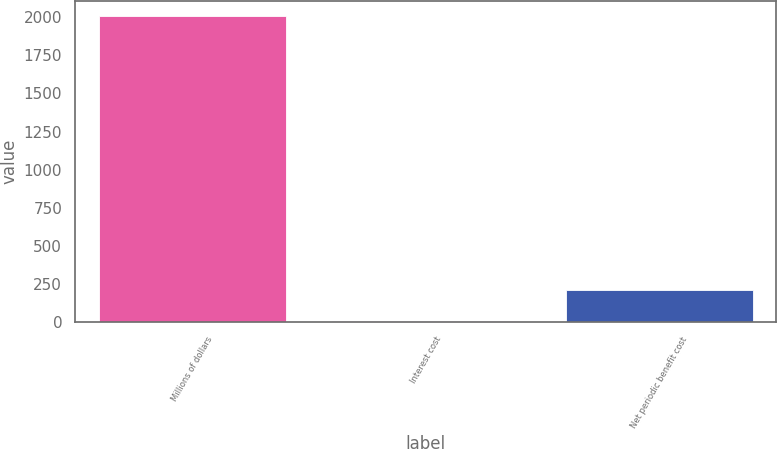<chart> <loc_0><loc_0><loc_500><loc_500><bar_chart><fcel>Millions of dollars<fcel>Interest cost<fcel>Net periodic benefit cost<nl><fcel>2006<fcel>9<fcel>208.7<nl></chart> 